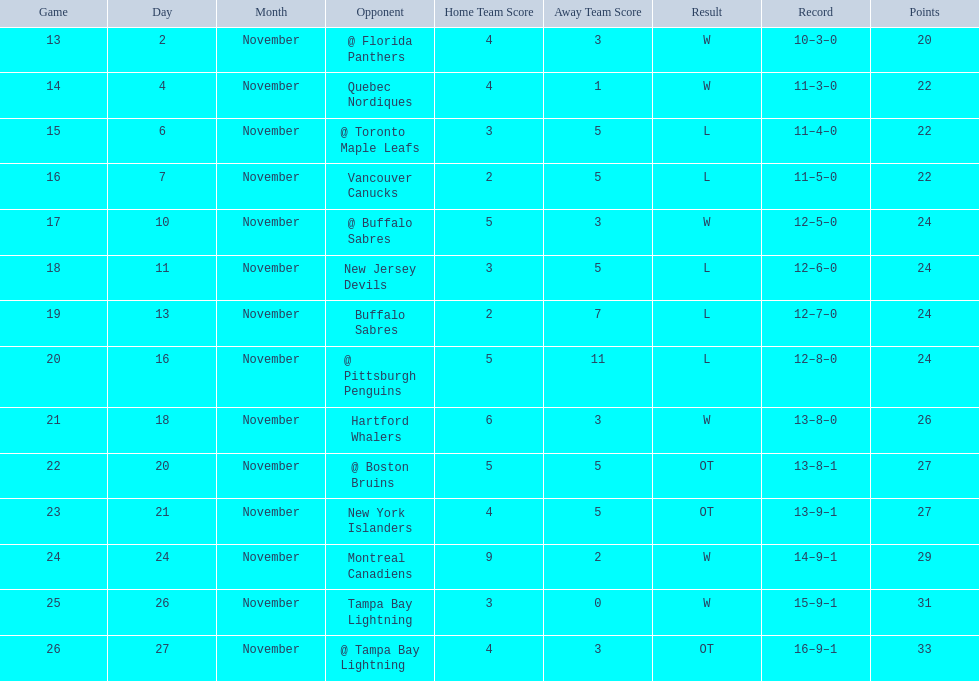Who had the most assists on the 1993-1994 flyers? Mark Recchi. 